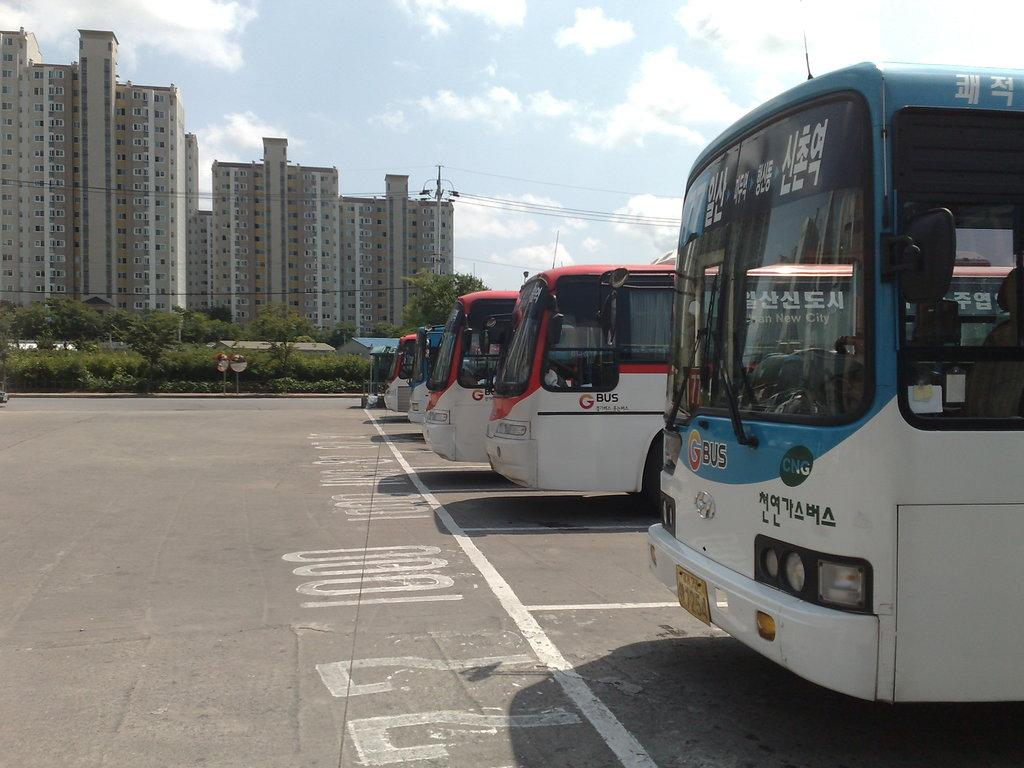<image>
Present a compact description of the photo's key features. Several busses made by GBus sit in a parking lot. 